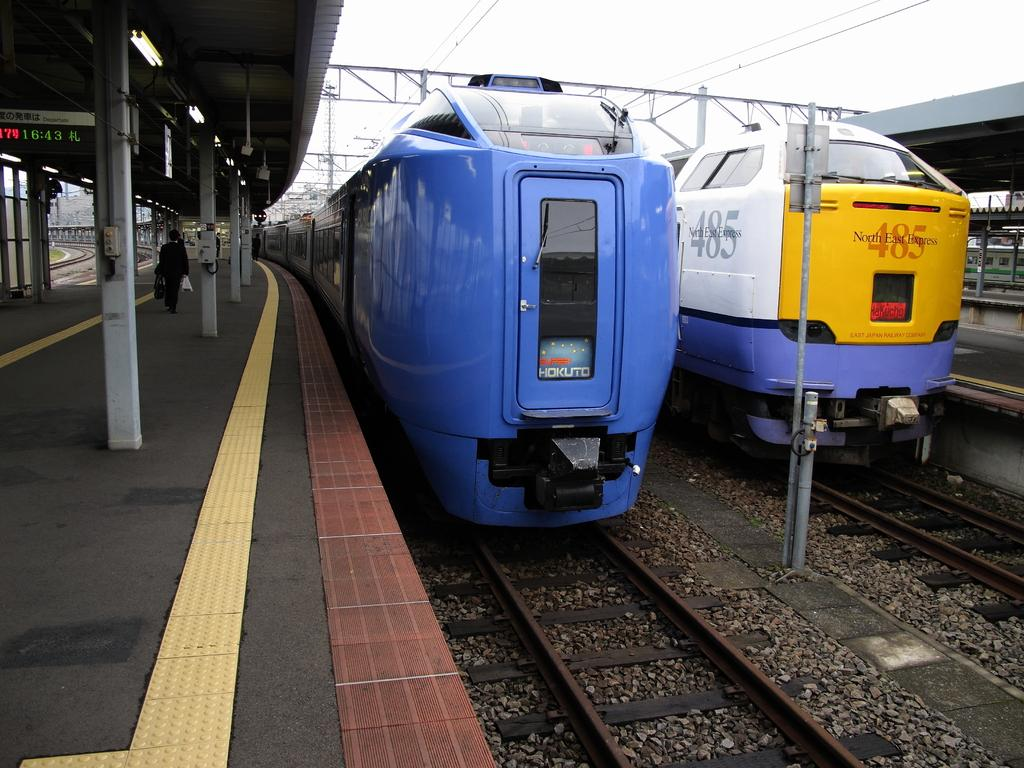<image>
Create a compact narrative representing the image presented. A blue bullet train that says Hokuto on the front of it. 